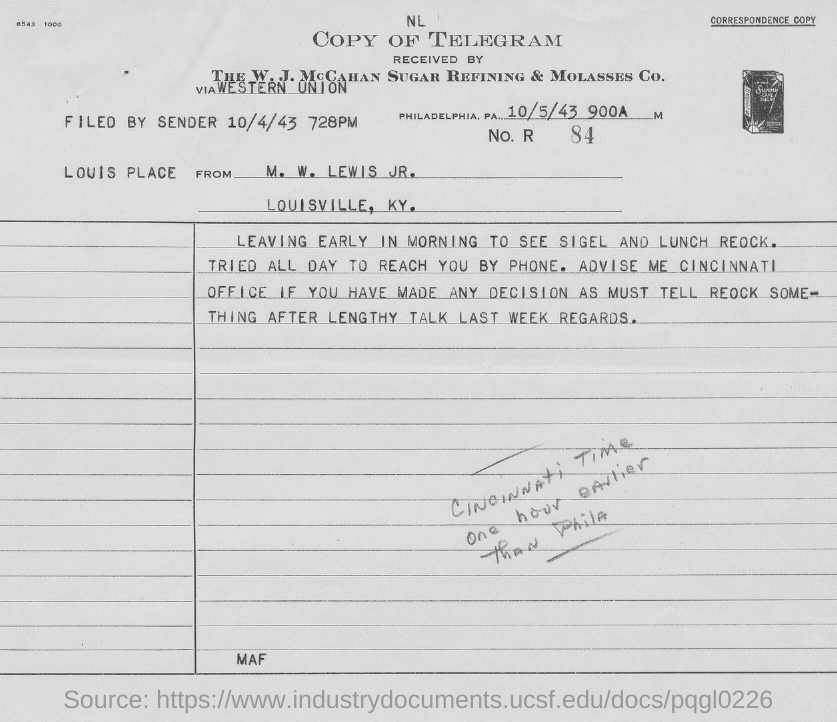Who is this letter from?
Provide a succinct answer. M. W. Lewis JR. When is it filed by sender?
Keep it short and to the point. 10/4/43. 